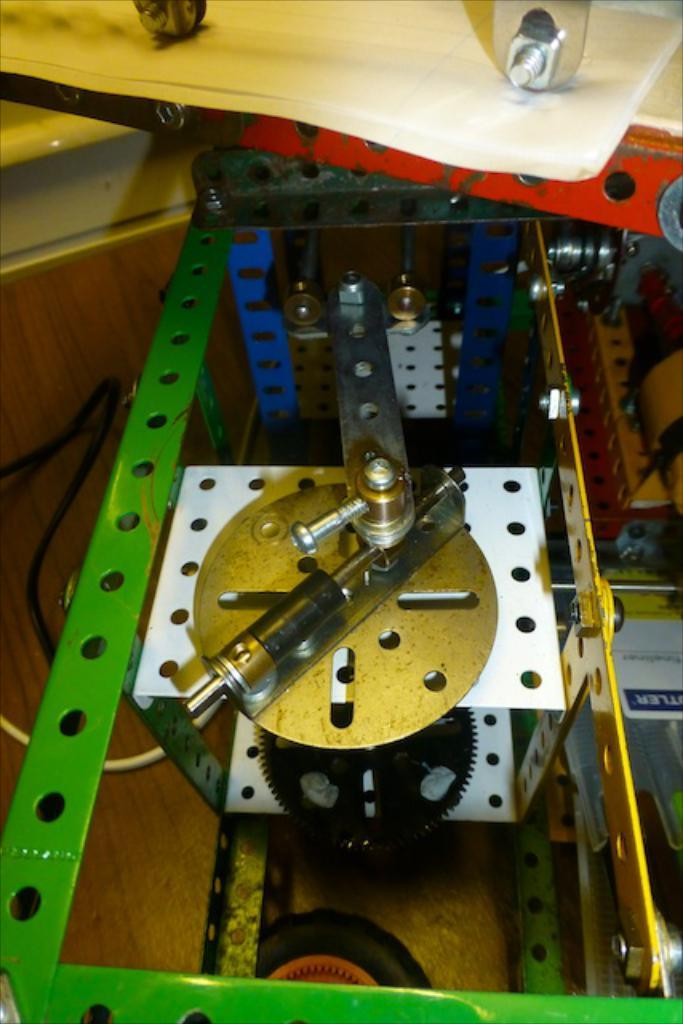What is the main object in the image? There is a machine in the image. What can be seen in the background of the image? There is a ground visible in the background of the image. Where is the house located in the image? There is no house present in the image. What type of ornament is hanging from the machine in the image? There is no ornament present in the image; only the machine is visible. 